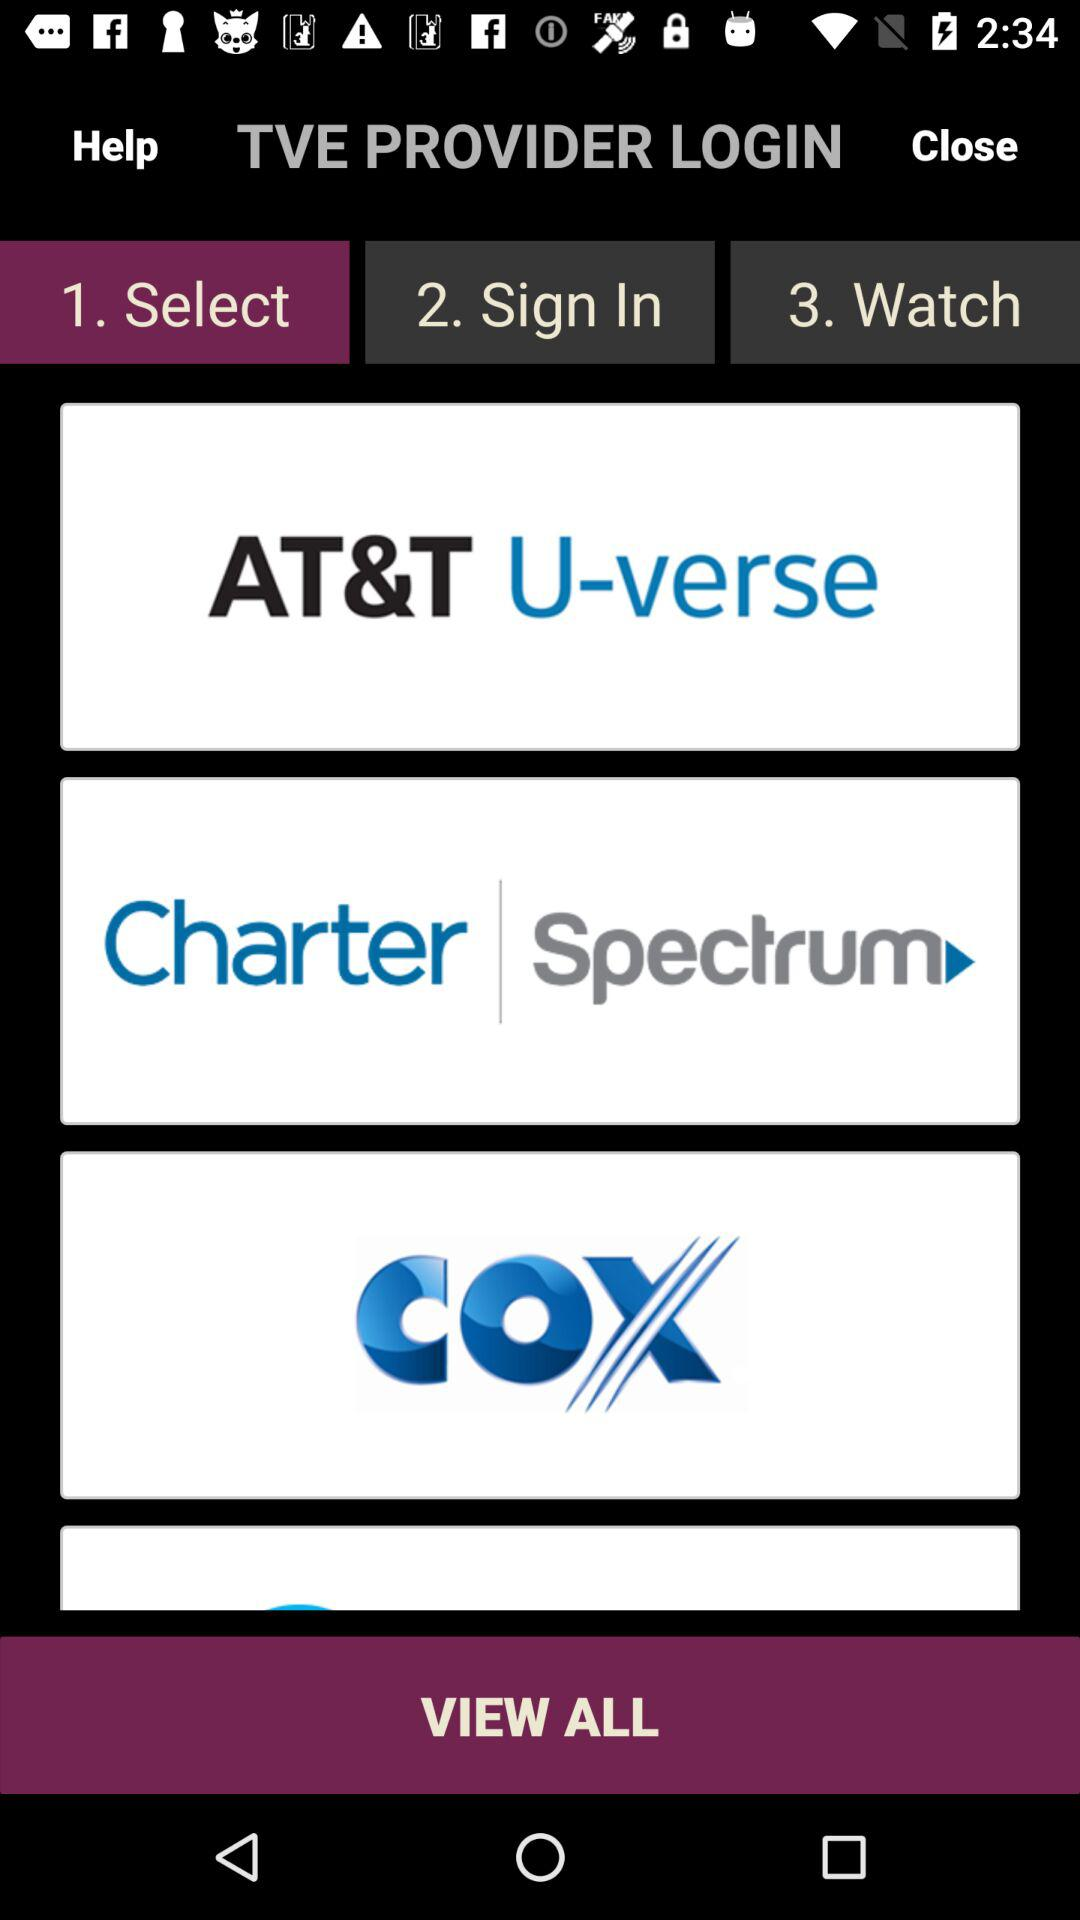What are the names of the TVE providers? The names of the TVE providers are "AT&T U-verse", "Charter | Spectrum" and "COX". 